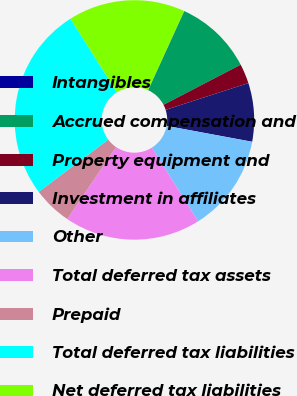Convert chart to OTSL. <chart><loc_0><loc_0><loc_500><loc_500><pie_chart><fcel>Intangibles<fcel>Accrued compensation and<fcel>Property equipment and<fcel>Investment in affiliates<fcel>Other<fcel>Total deferred tax assets<fcel>Prepaid<fcel>Total deferred tax liabilities<fcel>Net deferred tax liabilities<nl><fcel>0.03%<fcel>10.53%<fcel>2.65%<fcel>7.9%<fcel>13.15%<fcel>18.4%<fcel>5.28%<fcel>26.28%<fcel>15.78%<nl></chart> 